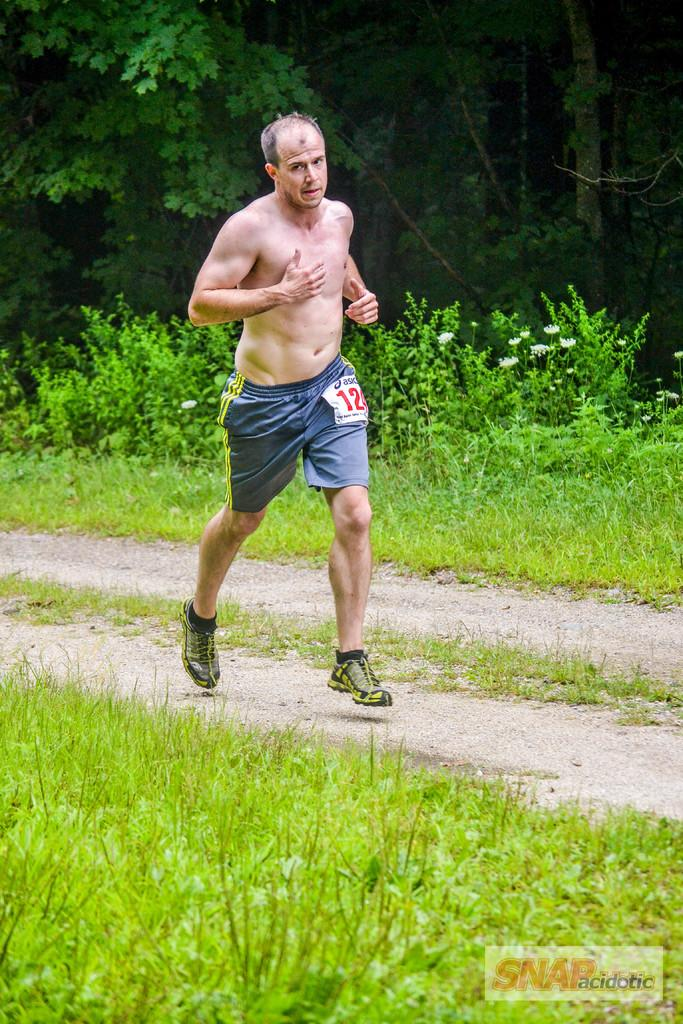What is the main subject of the image? There is a person in the image. What type of clothing is the person wearing? The person is wearing blue shorts and black shoes. What activity is the person engaged in? The person is running. What can be seen in the background of the image? There are trees and grass in the background of the image. What type of fowl can be seen in the image? There is no fowl present in the image; it features a person running in the background of trees and grass. What is the reason for the person running in the image? The image does not provide any information about the reason for the person running. 